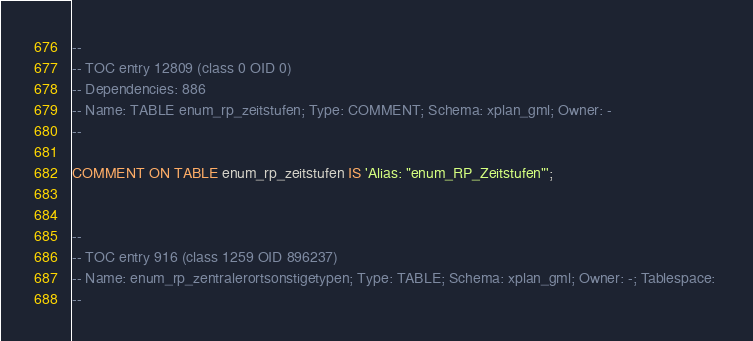<code> <loc_0><loc_0><loc_500><loc_500><_SQL_>
--
-- TOC entry 12809 (class 0 OID 0)
-- Dependencies: 886
-- Name: TABLE enum_rp_zeitstufen; Type: COMMENT; Schema: xplan_gml; Owner: -
--

COMMENT ON TABLE enum_rp_zeitstufen IS 'Alias: "enum_RP_Zeitstufen"';


--
-- TOC entry 916 (class 1259 OID 896237)
-- Name: enum_rp_zentralerortsonstigetypen; Type: TABLE; Schema: xplan_gml; Owner: -; Tablespace: 
--
</code> 